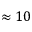<formula> <loc_0><loc_0><loc_500><loc_500>\approx 1 0</formula> 